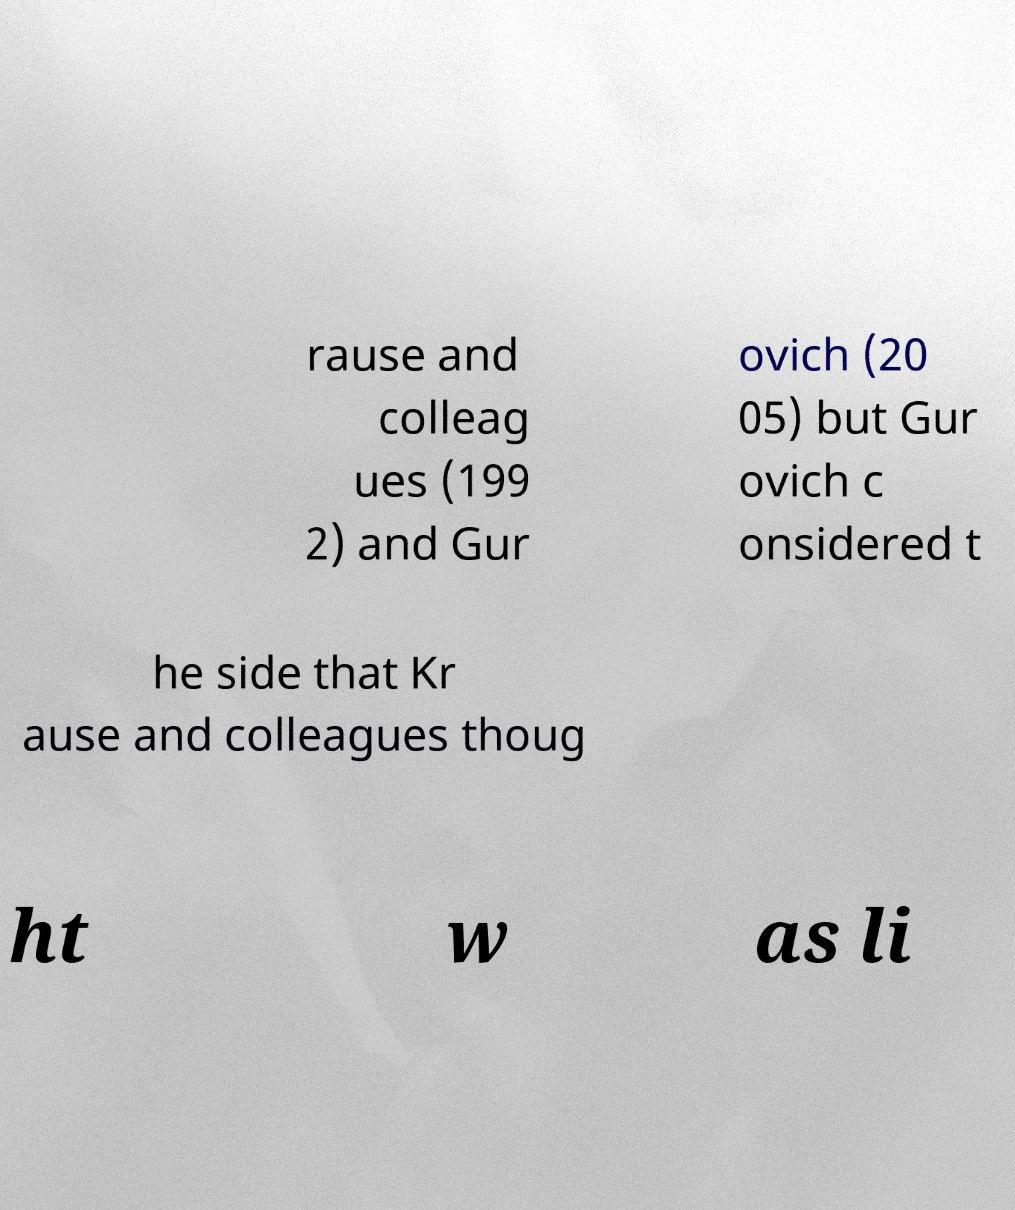There's text embedded in this image that I need extracted. Can you transcribe it verbatim? rause and colleag ues (199 2) and Gur ovich (20 05) but Gur ovich c onsidered t he side that Kr ause and colleagues thoug ht w as li 